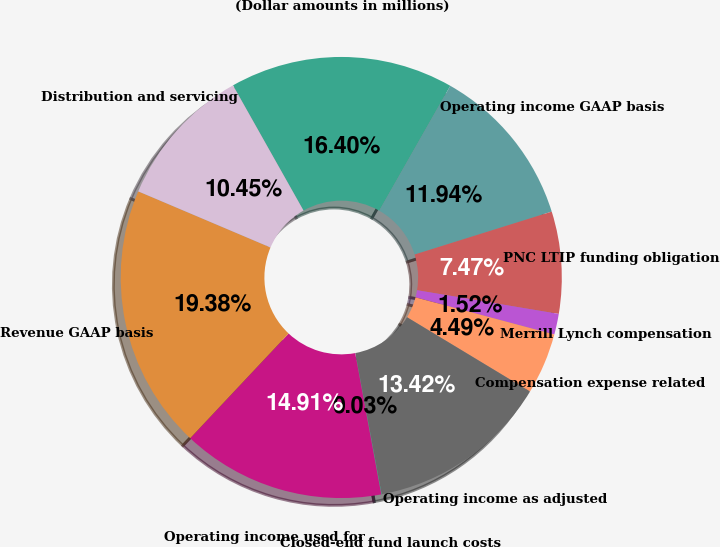Convert chart to OTSL. <chart><loc_0><loc_0><loc_500><loc_500><pie_chart><fcel>(Dollar amounts in millions)<fcel>Operating income GAAP basis<fcel>PNC LTIP funding obligation<fcel>Merrill Lynch compensation<fcel>Compensation expense related<fcel>Operating income as adjusted<fcel>Closed-end fund launch costs<fcel>Operating income used for<fcel>Revenue GAAP basis<fcel>Distribution and servicing<nl><fcel>16.4%<fcel>11.94%<fcel>7.47%<fcel>1.52%<fcel>4.49%<fcel>13.42%<fcel>0.03%<fcel>14.91%<fcel>19.38%<fcel>10.45%<nl></chart> 